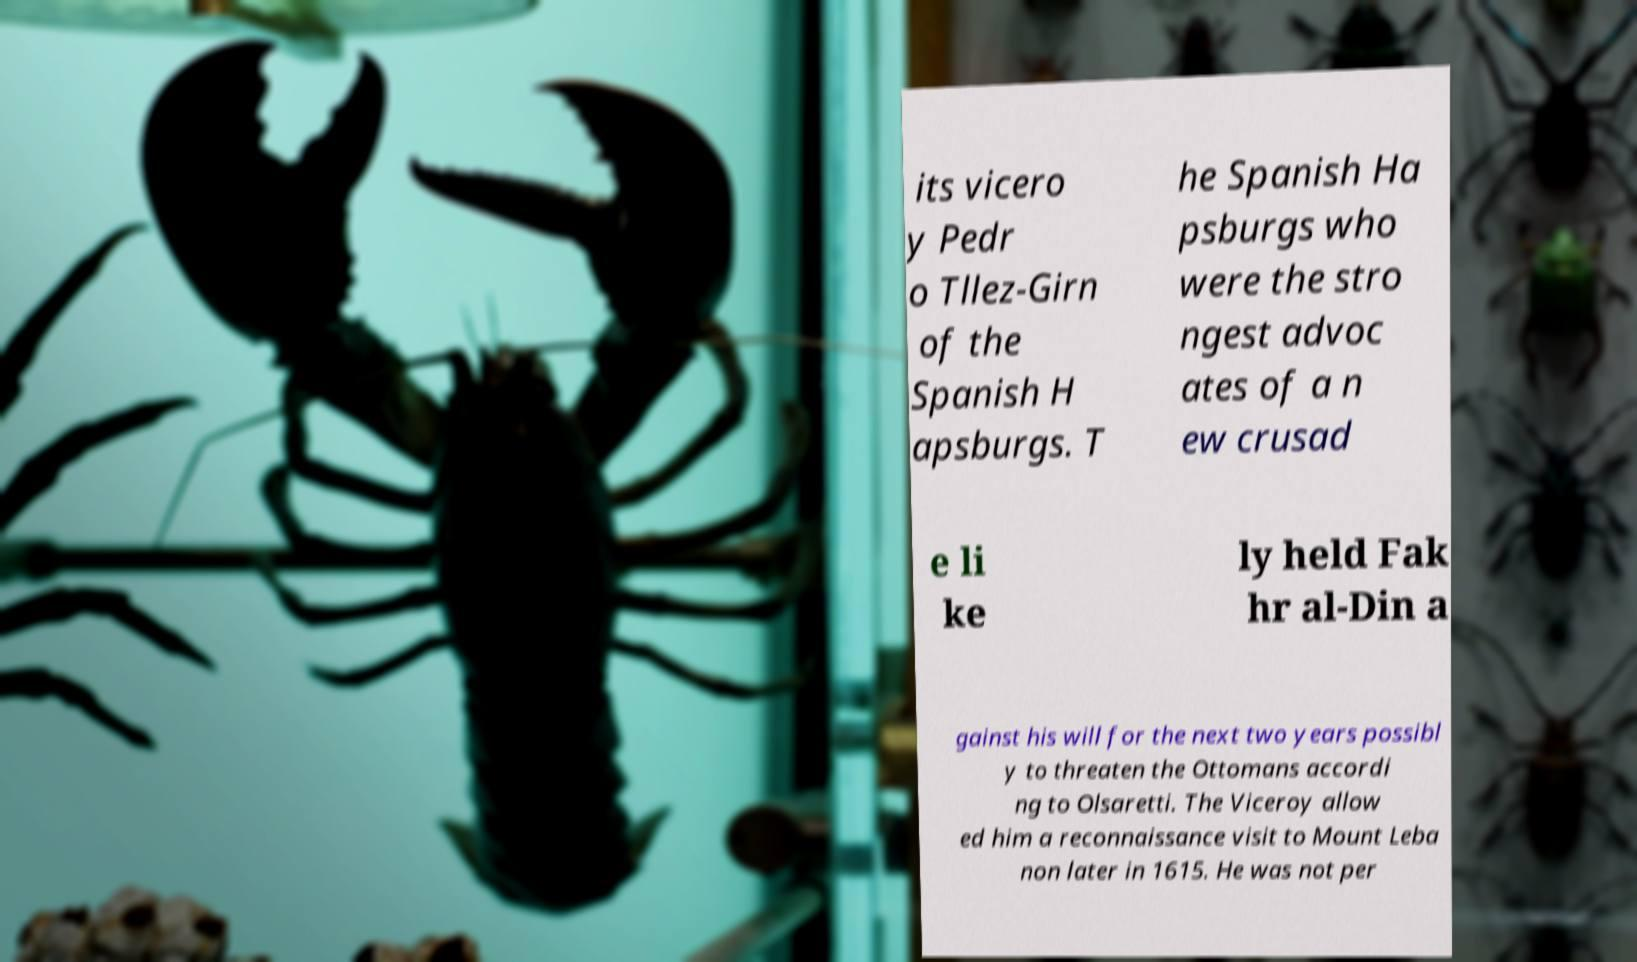What messages or text are displayed in this image? I need them in a readable, typed format. its vicero y Pedr o Tllez-Girn of the Spanish H apsburgs. T he Spanish Ha psburgs who were the stro ngest advoc ates of a n ew crusad e li ke ly held Fak hr al-Din a gainst his will for the next two years possibl y to threaten the Ottomans accordi ng to Olsaretti. The Viceroy allow ed him a reconnaissance visit to Mount Leba non later in 1615. He was not per 